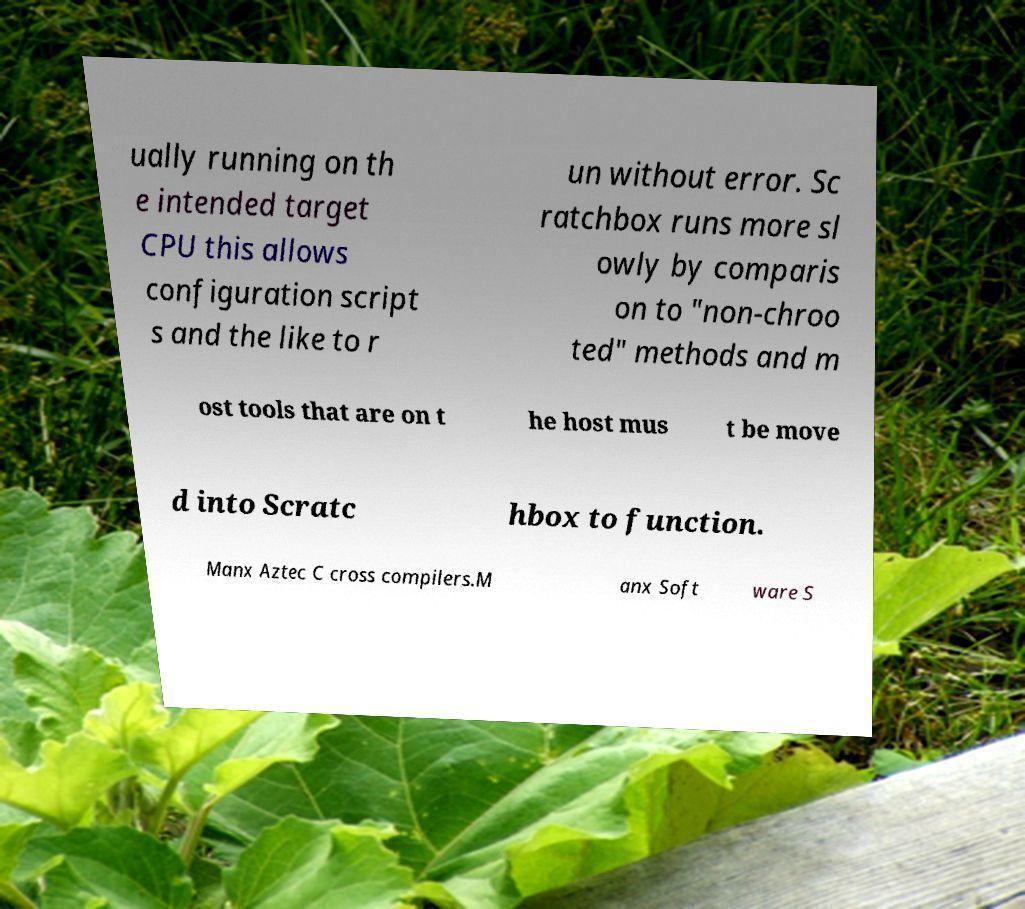Could you assist in decoding the text presented in this image and type it out clearly? ually running on th e intended target CPU this allows configuration script s and the like to r un without error. Sc ratchbox runs more sl owly by comparis on to "non-chroo ted" methods and m ost tools that are on t he host mus t be move d into Scratc hbox to function. Manx Aztec C cross compilers.M anx Soft ware S 